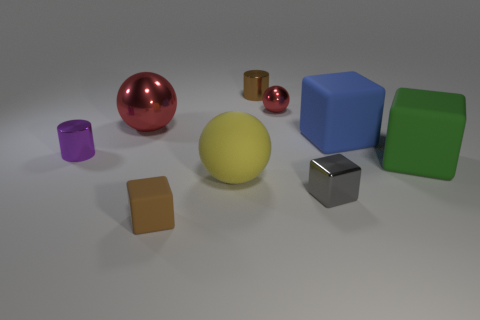What number of objects are either small things behind the tiny rubber block or tiny blocks that are right of the small red shiny ball?
Keep it short and to the point. 4. How many other things are the same color as the shiny cube?
Ensure brevity in your answer.  0. Is the number of metal cylinders right of the big blue matte object greater than the number of small purple metal things that are on the right side of the green matte cube?
Make the answer very short. No. Is there anything else that is the same size as the brown metal thing?
Offer a terse response. Yes. How many balls are either large metallic objects or big yellow matte things?
Keep it short and to the point. 2. What number of things are either small cylinders to the right of the yellow matte sphere or green rubber things?
Your response must be concise. 2. There is a big matte object behind the tiny shiny cylinder that is left of the matte thing that is in front of the gray block; what is its shape?
Your answer should be very brief. Cube. What number of large yellow rubber things are the same shape as the blue object?
Ensure brevity in your answer.  0. There is a ball that is the same color as the large metal thing; what is its material?
Your answer should be compact. Metal. Do the blue cube and the small purple thing have the same material?
Make the answer very short. No. 